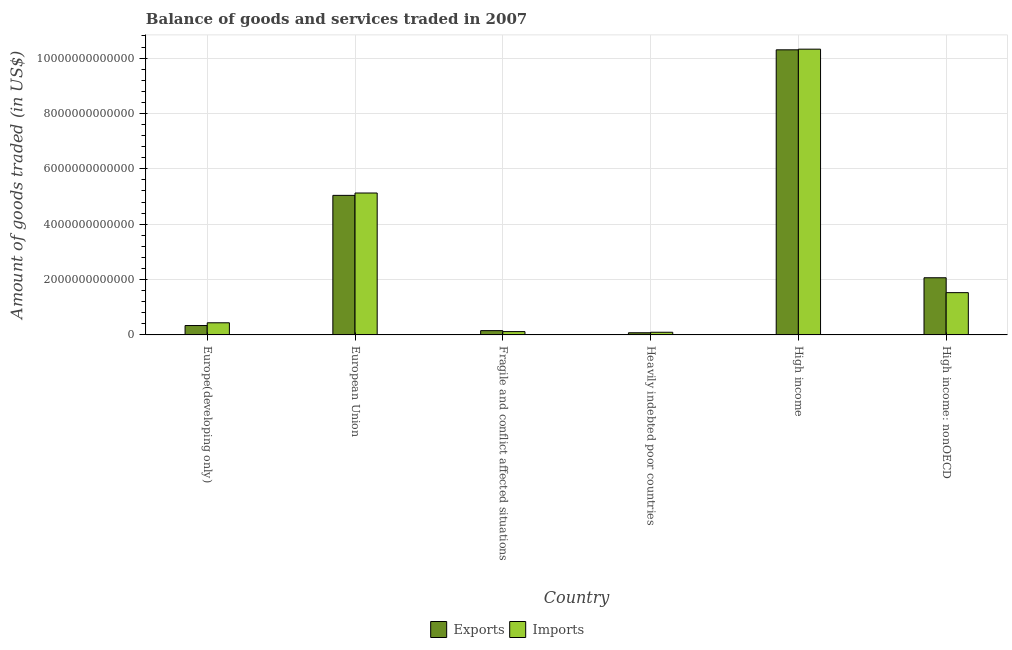How many groups of bars are there?
Offer a very short reply. 6. How many bars are there on the 2nd tick from the left?
Your answer should be very brief. 2. How many bars are there on the 2nd tick from the right?
Make the answer very short. 2. What is the label of the 1st group of bars from the left?
Provide a succinct answer. Europe(developing only). What is the amount of goods imported in Europe(developing only)?
Your answer should be very brief. 4.38e+11. Across all countries, what is the maximum amount of goods imported?
Provide a succinct answer. 1.03e+13. Across all countries, what is the minimum amount of goods imported?
Provide a succinct answer. 9.61e+1. In which country was the amount of goods imported minimum?
Keep it short and to the point. Heavily indebted poor countries. What is the total amount of goods exported in the graph?
Your answer should be very brief. 1.80e+13. What is the difference between the amount of goods exported in Europe(developing only) and that in European Union?
Offer a terse response. -4.70e+12. What is the difference between the amount of goods imported in Heavily indebted poor countries and the amount of goods exported in High income: nonOECD?
Keep it short and to the point. -1.97e+12. What is the average amount of goods imported per country?
Provide a short and direct response. 2.94e+12. What is the difference between the amount of goods exported and amount of goods imported in Fragile and conflict affected situations?
Give a very brief answer. 3.52e+1. In how many countries, is the amount of goods exported greater than 4400000000000 US$?
Your response must be concise. 2. What is the ratio of the amount of goods exported in Fragile and conflict affected situations to that in High income?
Offer a very short reply. 0.02. What is the difference between the highest and the second highest amount of goods exported?
Offer a terse response. 5.26e+12. What is the difference between the highest and the lowest amount of goods exported?
Offer a very short reply. 1.02e+13. What does the 1st bar from the left in High income: nonOECD represents?
Your answer should be very brief. Exports. What does the 2nd bar from the right in Heavily indebted poor countries represents?
Provide a succinct answer. Exports. How many countries are there in the graph?
Give a very brief answer. 6. What is the difference between two consecutive major ticks on the Y-axis?
Make the answer very short. 2.00e+12. Where does the legend appear in the graph?
Your response must be concise. Bottom center. What is the title of the graph?
Your answer should be very brief. Balance of goods and services traded in 2007. Does "Investment in Transport" appear as one of the legend labels in the graph?
Provide a short and direct response. No. What is the label or title of the Y-axis?
Offer a terse response. Amount of goods traded (in US$). What is the Amount of goods traded (in US$) of Exports in Europe(developing only)?
Your answer should be very brief. 3.39e+11. What is the Amount of goods traded (in US$) of Imports in Europe(developing only)?
Keep it short and to the point. 4.38e+11. What is the Amount of goods traded (in US$) of Exports in European Union?
Your answer should be very brief. 5.04e+12. What is the Amount of goods traded (in US$) in Imports in European Union?
Offer a very short reply. 5.13e+12. What is the Amount of goods traded (in US$) in Exports in Fragile and conflict affected situations?
Provide a short and direct response. 1.55e+11. What is the Amount of goods traded (in US$) of Imports in Fragile and conflict affected situations?
Ensure brevity in your answer.  1.19e+11. What is the Amount of goods traded (in US$) in Exports in Heavily indebted poor countries?
Give a very brief answer. 7.76e+1. What is the Amount of goods traded (in US$) of Imports in Heavily indebted poor countries?
Ensure brevity in your answer.  9.61e+1. What is the Amount of goods traded (in US$) in Exports in High income?
Make the answer very short. 1.03e+13. What is the Amount of goods traded (in US$) of Imports in High income?
Your answer should be very brief. 1.03e+13. What is the Amount of goods traded (in US$) in Exports in High income: nonOECD?
Offer a terse response. 2.06e+12. What is the Amount of goods traded (in US$) in Imports in High income: nonOECD?
Give a very brief answer. 1.53e+12. Across all countries, what is the maximum Amount of goods traded (in US$) of Exports?
Offer a terse response. 1.03e+13. Across all countries, what is the maximum Amount of goods traded (in US$) of Imports?
Your answer should be very brief. 1.03e+13. Across all countries, what is the minimum Amount of goods traded (in US$) of Exports?
Provide a short and direct response. 7.76e+1. Across all countries, what is the minimum Amount of goods traded (in US$) of Imports?
Your response must be concise. 9.61e+1. What is the total Amount of goods traded (in US$) of Exports in the graph?
Offer a very short reply. 1.80e+13. What is the total Amount of goods traded (in US$) of Imports in the graph?
Ensure brevity in your answer.  1.76e+13. What is the difference between the Amount of goods traded (in US$) of Exports in Europe(developing only) and that in European Union?
Ensure brevity in your answer.  -4.70e+12. What is the difference between the Amount of goods traded (in US$) in Imports in Europe(developing only) and that in European Union?
Offer a very short reply. -4.69e+12. What is the difference between the Amount of goods traded (in US$) of Exports in Europe(developing only) and that in Fragile and conflict affected situations?
Make the answer very short. 1.84e+11. What is the difference between the Amount of goods traded (in US$) of Imports in Europe(developing only) and that in Fragile and conflict affected situations?
Your answer should be compact. 3.18e+11. What is the difference between the Amount of goods traded (in US$) of Exports in Europe(developing only) and that in Heavily indebted poor countries?
Make the answer very short. 2.61e+11. What is the difference between the Amount of goods traded (in US$) of Imports in Europe(developing only) and that in Heavily indebted poor countries?
Your response must be concise. 3.42e+11. What is the difference between the Amount of goods traded (in US$) in Exports in Europe(developing only) and that in High income?
Your answer should be compact. -9.96e+12. What is the difference between the Amount of goods traded (in US$) of Imports in Europe(developing only) and that in High income?
Provide a succinct answer. -9.89e+12. What is the difference between the Amount of goods traded (in US$) of Exports in Europe(developing only) and that in High income: nonOECD?
Make the answer very short. -1.73e+12. What is the difference between the Amount of goods traded (in US$) of Imports in Europe(developing only) and that in High income: nonOECD?
Your answer should be compact. -1.09e+12. What is the difference between the Amount of goods traded (in US$) in Exports in European Union and that in Fragile and conflict affected situations?
Ensure brevity in your answer.  4.89e+12. What is the difference between the Amount of goods traded (in US$) of Imports in European Union and that in Fragile and conflict affected situations?
Your answer should be compact. 5.01e+12. What is the difference between the Amount of goods traded (in US$) of Exports in European Union and that in Heavily indebted poor countries?
Give a very brief answer. 4.96e+12. What is the difference between the Amount of goods traded (in US$) in Imports in European Union and that in Heavily indebted poor countries?
Your response must be concise. 5.03e+12. What is the difference between the Amount of goods traded (in US$) in Exports in European Union and that in High income?
Provide a short and direct response. -5.26e+12. What is the difference between the Amount of goods traded (in US$) of Imports in European Union and that in High income?
Offer a terse response. -5.20e+12. What is the difference between the Amount of goods traded (in US$) in Exports in European Union and that in High income: nonOECD?
Ensure brevity in your answer.  2.98e+12. What is the difference between the Amount of goods traded (in US$) of Imports in European Union and that in High income: nonOECD?
Offer a very short reply. 3.60e+12. What is the difference between the Amount of goods traded (in US$) of Exports in Fragile and conflict affected situations and that in Heavily indebted poor countries?
Ensure brevity in your answer.  7.71e+1. What is the difference between the Amount of goods traded (in US$) in Imports in Fragile and conflict affected situations and that in Heavily indebted poor countries?
Your response must be concise. 2.33e+1. What is the difference between the Amount of goods traded (in US$) of Exports in Fragile and conflict affected situations and that in High income?
Offer a very short reply. -1.01e+13. What is the difference between the Amount of goods traded (in US$) of Imports in Fragile and conflict affected situations and that in High income?
Make the answer very short. -1.02e+13. What is the difference between the Amount of goods traded (in US$) of Exports in Fragile and conflict affected situations and that in High income: nonOECD?
Provide a short and direct response. -1.91e+12. What is the difference between the Amount of goods traded (in US$) in Imports in Fragile and conflict affected situations and that in High income: nonOECD?
Keep it short and to the point. -1.41e+12. What is the difference between the Amount of goods traded (in US$) in Exports in Heavily indebted poor countries and that in High income?
Offer a very short reply. -1.02e+13. What is the difference between the Amount of goods traded (in US$) of Imports in Heavily indebted poor countries and that in High income?
Ensure brevity in your answer.  -1.02e+13. What is the difference between the Amount of goods traded (in US$) of Exports in Heavily indebted poor countries and that in High income: nonOECD?
Provide a succinct answer. -1.99e+12. What is the difference between the Amount of goods traded (in US$) in Imports in Heavily indebted poor countries and that in High income: nonOECD?
Provide a short and direct response. -1.43e+12. What is the difference between the Amount of goods traded (in US$) in Exports in High income and that in High income: nonOECD?
Your answer should be compact. 8.24e+12. What is the difference between the Amount of goods traded (in US$) in Imports in High income and that in High income: nonOECD?
Offer a very short reply. 8.80e+12. What is the difference between the Amount of goods traded (in US$) of Exports in Europe(developing only) and the Amount of goods traded (in US$) of Imports in European Union?
Your response must be concise. -4.79e+12. What is the difference between the Amount of goods traded (in US$) of Exports in Europe(developing only) and the Amount of goods traded (in US$) of Imports in Fragile and conflict affected situations?
Provide a succinct answer. 2.19e+11. What is the difference between the Amount of goods traded (in US$) in Exports in Europe(developing only) and the Amount of goods traded (in US$) in Imports in Heavily indebted poor countries?
Your answer should be very brief. 2.43e+11. What is the difference between the Amount of goods traded (in US$) in Exports in Europe(developing only) and the Amount of goods traded (in US$) in Imports in High income?
Ensure brevity in your answer.  -9.99e+12. What is the difference between the Amount of goods traded (in US$) in Exports in Europe(developing only) and the Amount of goods traded (in US$) in Imports in High income: nonOECD?
Provide a succinct answer. -1.19e+12. What is the difference between the Amount of goods traded (in US$) of Exports in European Union and the Amount of goods traded (in US$) of Imports in Fragile and conflict affected situations?
Provide a succinct answer. 4.92e+12. What is the difference between the Amount of goods traded (in US$) in Exports in European Union and the Amount of goods traded (in US$) in Imports in Heavily indebted poor countries?
Your response must be concise. 4.95e+12. What is the difference between the Amount of goods traded (in US$) in Exports in European Union and the Amount of goods traded (in US$) in Imports in High income?
Make the answer very short. -5.28e+12. What is the difference between the Amount of goods traded (in US$) of Exports in European Union and the Amount of goods traded (in US$) of Imports in High income: nonOECD?
Give a very brief answer. 3.51e+12. What is the difference between the Amount of goods traded (in US$) of Exports in Fragile and conflict affected situations and the Amount of goods traded (in US$) of Imports in Heavily indebted poor countries?
Offer a terse response. 5.86e+1. What is the difference between the Amount of goods traded (in US$) of Exports in Fragile and conflict affected situations and the Amount of goods traded (in US$) of Imports in High income?
Your answer should be compact. -1.02e+13. What is the difference between the Amount of goods traded (in US$) in Exports in Fragile and conflict affected situations and the Amount of goods traded (in US$) in Imports in High income: nonOECD?
Your answer should be very brief. -1.37e+12. What is the difference between the Amount of goods traded (in US$) in Exports in Heavily indebted poor countries and the Amount of goods traded (in US$) in Imports in High income?
Give a very brief answer. -1.02e+13. What is the difference between the Amount of goods traded (in US$) in Exports in Heavily indebted poor countries and the Amount of goods traded (in US$) in Imports in High income: nonOECD?
Offer a terse response. -1.45e+12. What is the difference between the Amount of goods traded (in US$) in Exports in High income and the Amount of goods traded (in US$) in Imports in High income: nonOECD?
Offer a very short reply. 8.77e+12. What is the average Amount of goods traded (in US$) in Exports per country?
Offer a terse response. 3.00e+12. What is the average Amount of goods traded (in US$) in Imports per country?
Offer a very short reply. 2.94e+12. What is the difference between the Amount of goods traded (in US$) in Exports and Amount of goods traded (in US$) in Imports in Europe(developing only)?
Keep it short and to the point. -9.91e+1. What is the difference between the Amount of goods traded (in US$) of Exports and Amount of goods traded (in US$) of Imports in European Union?
Your answer should be very brief. -8.51e+1. What is the difference between the Amount of goods traded (in US$) in Exports and Amount of goods traded (in US$) in Imports in Fragile and conflict affected situations?
Keep it short and to the point. 3.52e+1. What is the difference between the Amount of goods traded (in US$) in Exports and Amount of goods traded (in US$) in Imports in Heavily indebted poor countries?
Offer a very short reply. -1.85e+1. What is the difference between the Amount of goods traded (in US$) in Exports and Amount of goods traded (in US$) in Imports in High income?
Your answer should be very brief. -2.40e+1. What is the difference between the Amount of goods traded (in US$) of Exports and Amount of goods traded (in US$) of Imports in High income: nonOECD?
Your answer should be compact. 5.38e+11. What is the ratio of the Amount of goods traded (in US$) in Exports in Europe(developing only) to that in European Union?
Your answer should be compact. 0.07. What is the ratio of the Amount of goods traded (in US$) in Imports in Europe(developing only) to that in European Union?
Ensure brevity in your answer.  0.09. What is the ratio of the Amount of goods traded (in US$) of Exports in Europe(developing only) to that in Fragile and conflict affected situations?
Provide a short and direct response. 2.19. What is the ratio of the Amount of goods traded (in US$) in Imports in Europe(developing only) to that in Fragile and conflict affected situations?
Your response must be concise. 3.67. What is the ratio of the Amount of goods traded (in US$) in Exports in Europe(developing only) to that in Heavily indebted poor countries?
Make the answer very short. 4.37. What is the ratio of the Amount of goods traded (in US$) of Imports in Europe(developing only) to that in Heavily indebted poor countries?
Your answer should be very brief. 4.56. What is the ratio of the Amount of goods traded (in US$) of Exports in Europe(developing only) to that in High income?
Offer a terse response. 0.03. What is the ratio of the Amount of goods traded (in US$) in Imports in Europe(developing only) to that in High income?
Give a very brief answer. 0.04. What is the ratio of the Amount of goods traded (in US$) of Exports in Europe(developing only) to that in High income: nonOECD?
Your response must be concise. 0.16. What is the ratio of the Amount of goods traded (in US$) of Imports in Europe(developing only) to that in High income: nonOECD?
Ensure brevity in your answer.  0.29. What is the ratio of the Amount of goods traded (in US$) in Exports in European Union to that in Fragile and conflict affected situations?
Your response must be concise. 32.6. What is the ratio of the Amount of goods traded (in US$) of Imports in European Union to that in Fragile and conflict affected situations?
Offer a very short reply. 42.93. What is the ratio of the Amount of goods traded (in US$) of Exports in European Union to that in Heavily indebted poor countries?
Offer a very short reply. 64.99. What is the ratio of the Amount of goods traded (in US$) in Imports in European Union to that in Heavily indebted poor countries?
Offer a very short reply. 53.35. What is the ratio of the Amount of goods traded (in US$) of Exports in European Union to that in High income?
Make the answer very short. 0.49. What is the ratio of the Amount of goods traded (in US$) of Imports in European Union to that in High income?
Offer a very short reply. 0.5. What is the ratio of the Amount of goods traded (in US$) in Exports in European Union to that in High income: nonOECD?
Provide a succinct answer. 2.44. What is the ratio of the Amount of goods traded (in US$) in Imports in European Union to that in High income: nonOECD?
Your response must be concise. 3.36. What is the ratio of the Amount of goods traded (in US$) in Exports in Fragile and conflict affected situations to that in Heavily indebted poor countries?
Offer a terse response. 1.99. What is the ratio of the Amount of goods traded (in US$) of Imports in Fragile and conflict affected situations to that in Heavily indebted poor countries?
Provide a succinct answer. 1.24. What is the ratio of the Amount of goods traded (in US$) in Exports in Fragile and conflict affected situations to that in High income?
Ensure brevity in your answer.  0.01. What is the ratio of the Amount of goods traded (in US$) in Imports in Fragile and conflict affected situations to that in High income?
Your answer should be very brief. 0.01. What is the ratio of the Amount of goods traded (in US$) of Exports in Fragile and conflict affected situations to that in High income: nonOECD?
Give a very brief answer. 0.07. What is the ratio of the Amount of goods traded (in US$) in Imports in Fragile and conflict affected situations to that in High income: nonOECD?
Offer a terse response. 0.08. What is the ratio of the Amount of goods traded (in US$) of Exports in Heavily indebted poor countries to that in High income?
Make the answer very short. 0.01. What is the ratio of the Amount of goods traded (in US$) of Imports in Heavily indebted poor countries to that in High income?
Ensure brevity in your answer.  0.01. What is the ratio of the Amount of goods traded (in US$) in Exports in Heavily indebted poor countries to that in High income: nonOECD?
Offer a very short reply. 0.04. What is the ratio of the Amount of goods traded (in US$) in Imports in Heavily indebted poor countries to that in High income: nonOECD?
Your answer should be very brief. 0.06. What is the ratio of the Amount of goods traded (in US$) of Exports in High income to that in High income: nonOECD?
Offer a very short reply. 4.99. What is the ratio of the Amount of goods traded (in US$) of Imports in High income to that in High income: nonOECD?
Offer a terse response. 6.76. What is the difference between the highest and the second highest Amount of goods traded (in US$) in Exports?
Give a very brief answer. 5.26e+12. What is the difference between the highest and the second highest Amount of goods traded (in US$) in Imports?
Ensure brevity in your answer.  5.20e+12. What is the difference between the highest and the lowest Amount of goods traded (in US$) of Exports?
Keep it short and to the point. 1.02e+13. What is the difference between the highest and the lowest Amount of goods traded (in US$) in Imports?
Your response must be concise. 1.02e+13. 